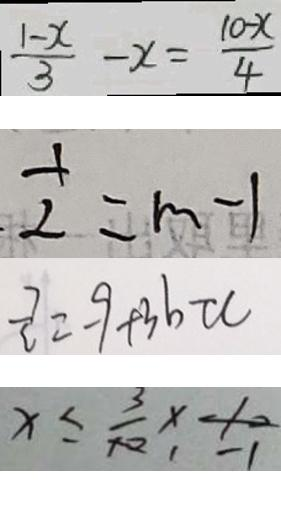<formula> <loc_0><loc_0><loc_500><loc_500>\frac { 1 - x } { 3 } - x = \frac { 1 0 - x } { 4 } 
 \frac { 1 } { 2 } = m - 1 
 \frac { 7 } { c } = - 9 + 3 b \tau c 
 x \leq \frac { 3 } { 1 0 } \times - 1 0</formula> 